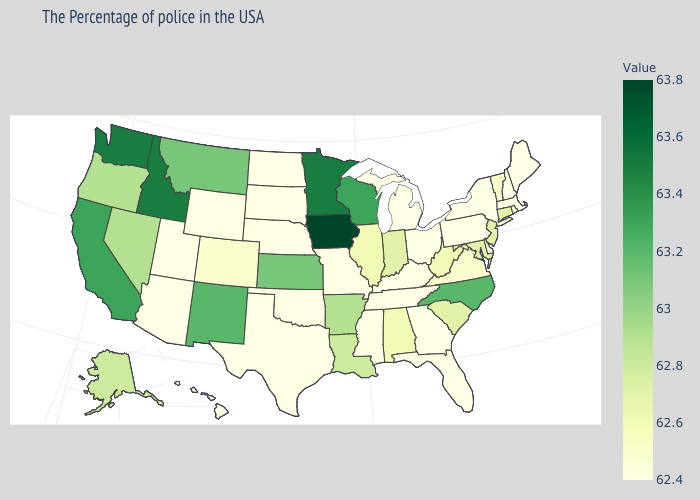Which states have the highest value in the USA?
Short answer required. Iowa. Which states hav the highest value in the South?
Short answer required. North Carolina. Which states have the lowest value in the USA?
Give a very brief answer. Maine, Massachusetts, Rhode Island, New Hampshire, New York, Delaware, Pennsylvania, Ohio, Florida, Georgia, Michigan, Kentucky, Tennessee, Mississippi, Missouri, Nebraska, Oklahoma, Texas, South Dakota, North Dakota, Wyoming, Utah, Arizona, Hawaii. Which states hav the highest value in the South?
Quick response, please. North Carolina. Does the map have missing data?
Concise answer only. No. Which states have the lowest value in the South?
Write a very short answer. Delaware, Florida, Georgia, Kentucky, Tennessee, Mississippi, Oklahoma, Texas. Does Missouri have the highest value in the USA?
Keep it brief. No. 